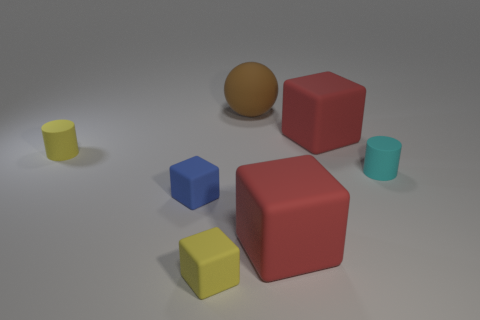What number of objects are large red objects behind the yellow cylinder or large red objects that are behind the cyan thing?
Your answer should be very brief. 1. Is the number of cylinders that are right of the large sphere greater than the number of small blue objects?
Your answer should be compact. No. How many brown blocks are the same size as the yellow cube?
Offer a very short reply. 0. Do the yellow thing that is behind the small cyan rubber cylinder and the brown sphere to the right of the tiny yellow cube have the same size?
Your answer should be compact. No. What is the size of the yellow object that is on the left side of the small blue matte thing?
Make the answer very short. Small. What is the size of the red rubber object that is behind the cylinder to the right of the large brown rubber object?
Offer a very short reply. Large. What material is the yellow thing that is the same size as the yellow cylinder?
Give a very brief answer. Rubber. There is a tiny yellow matte cube; are there any small objects on the left side of it?
Your answer should be compact. Yes. Are there an equal number of brown matte spheres behind the brown rubber ball and blocks?
Offer a very short reply. No. What is the shape of the blue rubber object that is the same size as the cyan thing?
Offer a terse response. Cube. 